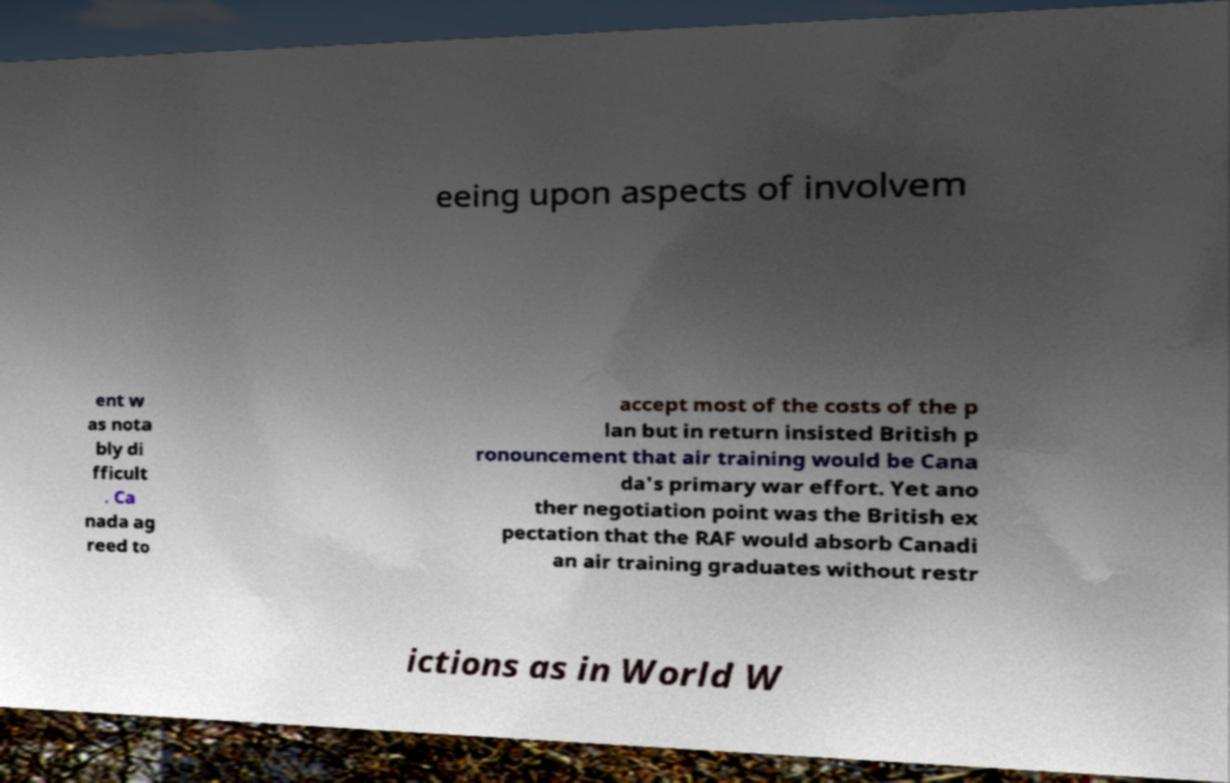For documentation purposes, I need the text within this image transcribed. Could you provide that? eeing upon aspects of involvem ent w as nota bly di fficult . Ca nada ag reed to accept most of the costs of the p lan but in return insisted British p ronouncement that air training would be Cana da's primary war effort. Yet ano ther negotiation point was the British ex pectation that the RAF would absorb Canadi an air training graduates without restr ictions as in World W 